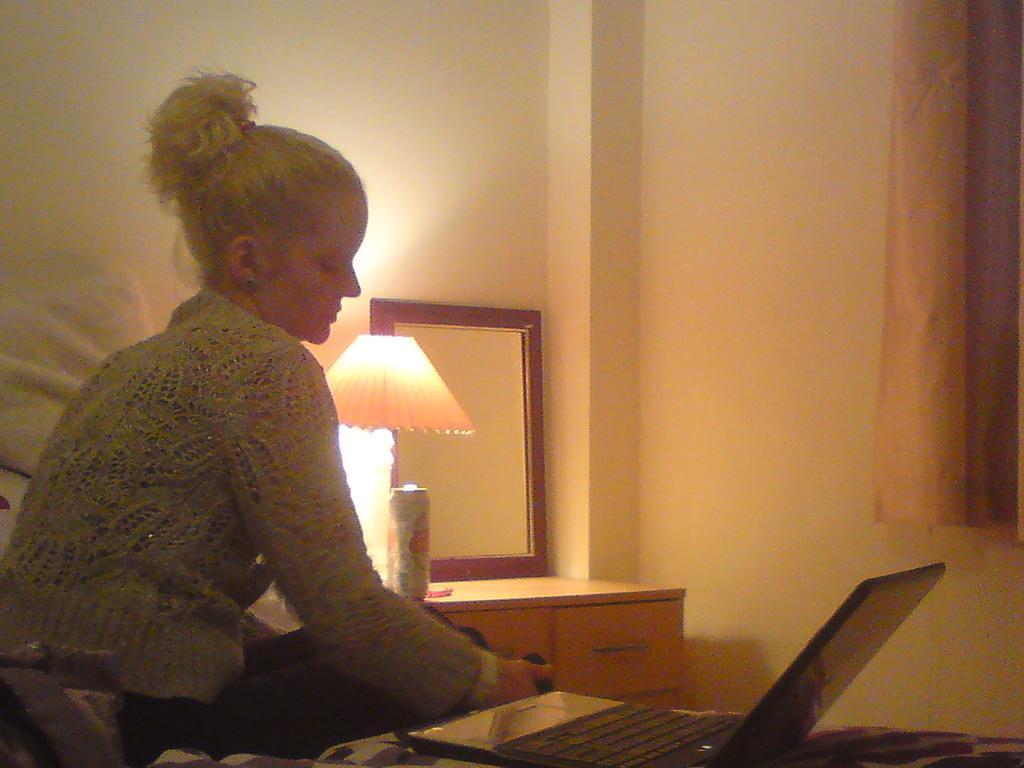Could you give a brief overview of what you see in this image? In the center of the image we can see one person is sitting on the bed and she is in a different costume. On the bed, we can see one laptop and some objects. In the background, there is a wall, curtain, one table, drawer, lamp, one can and a mirror. 